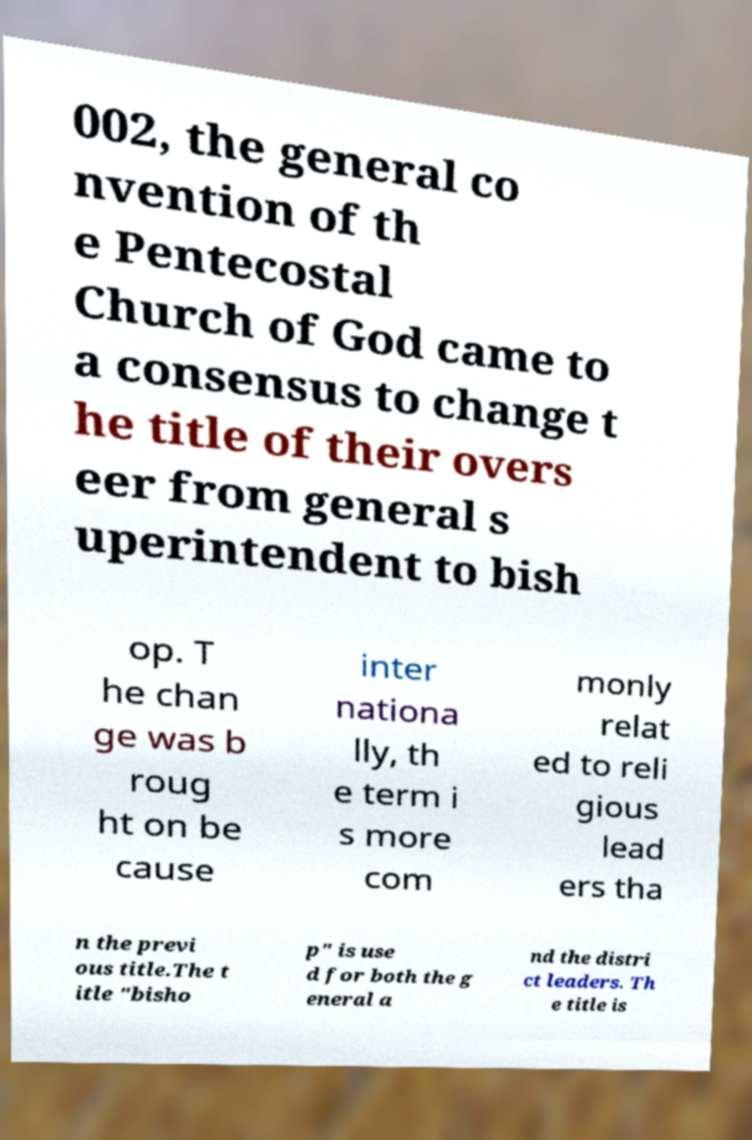What messages or text are displayed in this image? I need them in a readable, typed format. 002, the general co nvention of th e Pentecostal Church of God came to a consensus to change t he title of their overs eer from general s uperintendent to bish op. T he chan ge was b roug ht on be cause inter nationa lly, th e term i s more com monly relat ed to reli gious lead ers tha n the previ ous title.The t itle "bisho p" is use d for both the g eneral a nd the distri ct leaders. Th e title is 